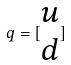<formula> <loc_0><loc_0><loc_500><loc_500>q = [ \begin{matrix} u \\ d \end{matrix} ]</formula> 